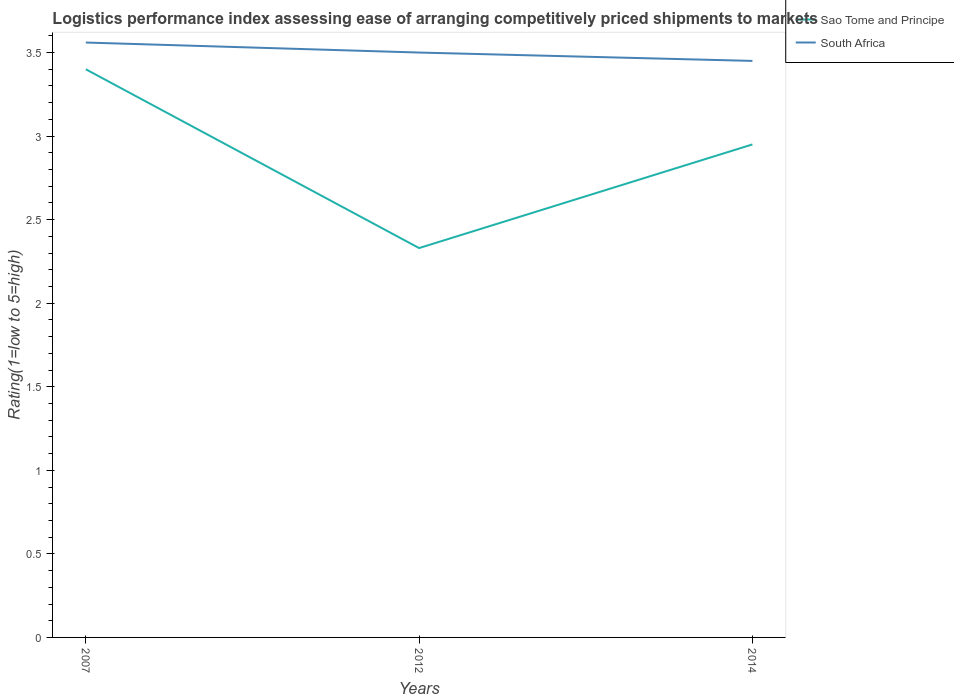How many different coloured lines are there?
Provide a succinct answer. 2. Does the line corresponding to Sao Tome and Principe intersect with the line corresponding to South Africa?
Your response must be concise. No. Is the number of lines equal to the number of legend labels?
Your answer should be compact. Yes. Across all years, what is the maximum Logistic performance index in Sao Tome and Principe?
Keep it short and to the point. 2.33. What is the total Logistic performance index in South Africa in the graph?
Make the answer very short. 0.05. What is the difference between the highest and the second highest Logistic performance index in South Africa?
Provide a short and direct response. 0.11. Is the Logistic performance index in Sao Tome and Principe strictly greater than the Logistic performance index in South Africa over the years?
Your response must be concise. Yes. What is the difference between two consecutive major ticks on the Y-axis?
Your answer should be very brief. 0.5. How are the legend labels stacked?
Your answer should be very brief. Vertical. What is the title of the graph?
Offer a very short reply. Logistics performance index assessing ease of arranging competitively priced shipments to markets. What is the label or title of the Y-axis?
Offer a terse response. Rating(1=low to 5=high). What is the Rating(1=low to 5=high) of South Africa in 2007?
Your response must be concise. 3.56. What is the Rating(1=low to 5=high) in Sao Tome and Principe in 2012?
Give a very brief answer. 2.33. What is the Rating(1=low to 5=high) in South Africa in 2012?
Keep it short and to the point. 3.5. What is the Rating(1=low to 5=high) of Sao Tome and Principe in 2014?
Provide a succinct answer. 2.95. What is the Rating(1=low to 5=high) in South Africa in 2014?
Keep it short and to the point. 3.45. Across all years, what is the maximum Rating(1=low to 5=high) in South Africa?
Offer a very short reply. 3.56. Across all years, what is the minimum Rating(1=low to 5=high) of Sao Tome and Principe?
Ensure brevity in your answer.  2.33. Across all years, what is the minimum Rating(1=low to 5=high) in South Africa?
Your answer should be very brief. 3.45. What is the total Rating(1=low to 5=high) of Sao Tome and Principe in the graph?
Your answer should be compact. 8.68. What is the total Rating(1=low to 5=high) in South Africa in the graph?
Give a very brief answer. 10.51. What is the difference between the Rating(1=low to 5=high) in Sao Tome and Principe in 2007 and that in 2012?
Ensure brevity in your answer.  1.07. What is the difference between the Rating(1=low to 5=high) in South Africa in 2007 and that in 2012?
Your response must be concise. 0.06. What is the difference between the Rating(1=low to 5=high) of Sao Tome and Principe in 2007 and that in 2014?
Offer a terse response. 0.45. What is the difference between the Rating(1=low to 5=high) in South Africa in 2007 and that in 2014?
Your answer should be very brief. 0.11. What is the difference between the Rating(1=low to 5=high) of Sao Tome and Principe in 2012 and that in 2014?
Offer a terse response. -0.62. What is the difference between the Rating(1=low to 5=high) in Sao Tome and Principe in 2007 and the Rating(1=low to 5=high) in South Africa in 2014?
Keep it short and to the point. -0.05. What is the difference between the Rating(1=low to 5=high) of Sao Tome and Principe in 2012 and the Rating(1=low to 5=high) of South Africa in 2014?
Keep it short and to the point. -1.12. What is the average Rating(1=low to 5=high) of Sao Tome and Principe per year?
Your answer should be compact. 2.89. What is the average Rating(1=low to 5=high) in South Africa per year?
Offer a very short reply. 3.5. In the year 2007, what is the difference between the Rating(1=low to 5=high) of Sao Tome and Principe and Rating(1=low to 5=high) of South Africa?
Provide a short and direct response. -0.16. In the year 2012, what is the difference between the Rating(1=low to 5=high) of Sao Tome and Principe and Rating(1=low to 5=high) of South Africa?
Give a very brief answer. -1.17. In the year 2014, what is the difference between the Rating(1=low to 5=high) of Sao Tome and Principe and Rating(1=low to 5=high) of South Africa?
Your answer should be very brief. -0.5. What is the ratio of the Rating(1=low to 5=high) of Sao Tome and Principe in 2007 to that in 2012?
Your answer should be compact. 1.46. What is the ratio of the Rating(1=low to 5=high) of South Africa in 2007 to that in 2012?
Your response must be concise. 1.02. What is the ratio of the Rating(1=low to 5=high) of Sao Tome and Principe in 2007 to that in 2014?
Your answer should be compact. 1.15. What is the ratio of the Rating(1=low to 5=high) of South Africa in 2007 to that in 2014?
Offer a terse response. 1.03. What is the ratio of the Rating(1=low to 5=high) of Sao Tome and Principe in 2012 to that in 2014?
Offer a very short reply. 0.79. What is the ratio of the Rating(1=low to 5=high) of South Africa in 2012 to that in 2014?
Provide a short and direct response. 1.01. What is the difference between the highest and the second highest Rating(1=low to 5=high) of Sao Tome and Principe?
Provide a succinct answer. 0.45. What is the difference between the highest and the lowest Rating(1=low to 5=high) of Sao Tome and Principe?
Your response must be concise. 1.07. What is the difference between the highest and the lowest Rating(1=low to 5=high) of South Africa?
Keep it short and to the point. 0.11. 